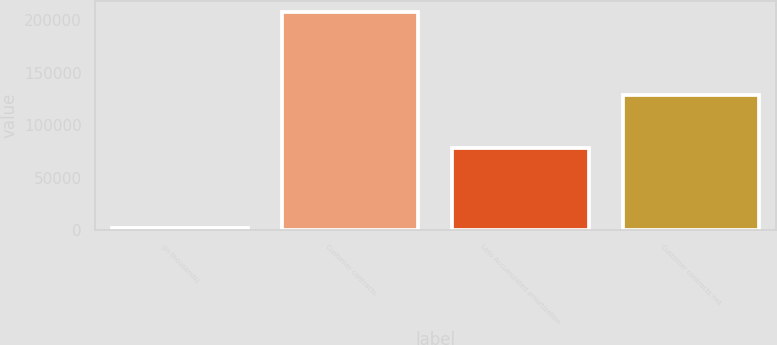Convert chart to OTSL. <chart><loc_0><loc_0><loc_500><loc_500><bar_chart><fcel>(in thousands)<fcel>Customer contracts<fcel>Less Accumulated amortization<fcel>Customer contracts net<nl><fcel>2008<fcel>207789<fcel>78697<fcel>129092<nl></chart> 